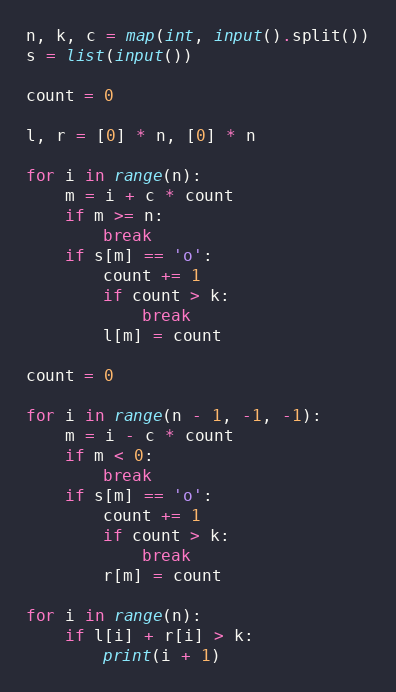Convert code to text. <code><loc_0><loc_0><loc_500><loc_500><_Python_>n, k, c = map(int, input().split())
s = list(input())

count = 0

l, r = [0] * n, [0] * n

for i in range(n):
    m = i + c * count
    if m >= n:
        break
    if s[m] == 'o':
        count += 1
        if count > k:
            break
        l[m] = count

count = 0

for i in range(n - 1, -1, -1):
    m = i - c * count
    if m < 0:
        break
    if s[m] == 'o':
        count += 1
        if count > k:
            break
        r[m] = count

for i in range(n):
    if l[i] + r[i] > k:
        print(i + 1)
</code> 